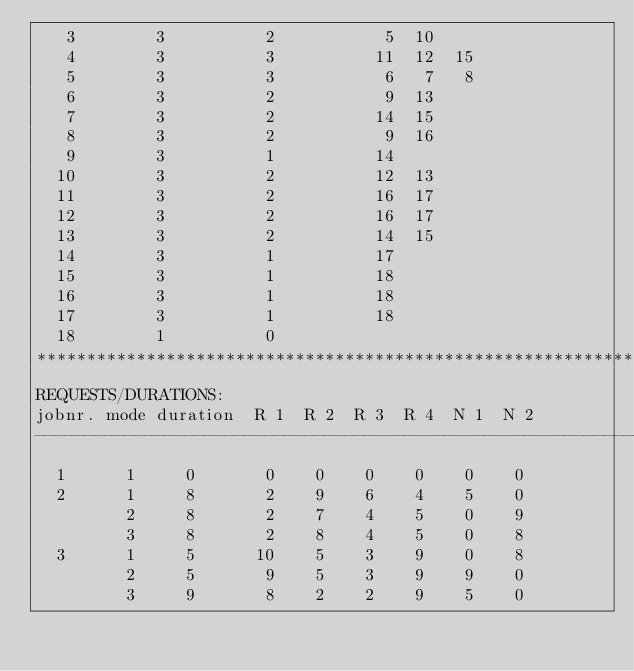Convert code to text. <code><loc_0><loc_0><loc_500><loc_500><_ObjectiveC_>   3        3          2           5  10
   4        3          3          11  12  15
   5        3          3           6   7   8
   6        3          2           9  13
   7        3          2          14  15
   8        3          2           9  16
   9        3          1          14
  10        3          2          12  13
  11        3          2          16  17
  12        3          2          16  17
  13        3          2          14  15
  14        3          1          17
  15        3          1          18
  16        3          1          18
  17        3          1          18
  18        1          0        
************************************************************************
REQUESTS/DURATIONS:
jobnr. mode duration  R 1  R 2  R 3  R 4  N 1  N 2
------------------------------------------------------------------------
  1      1     0       0    0    0    0    0    0
  2      1     8       2    9    6    4    5    0
         2     8       2    7    4    5    0    9
         3     8       2    8    4    5    0    8
  3      1     5      10    5    3    9    0    8
         2     5       9    5    3    9    9    0
         3     9       8    2    2    9    5    0</code> 